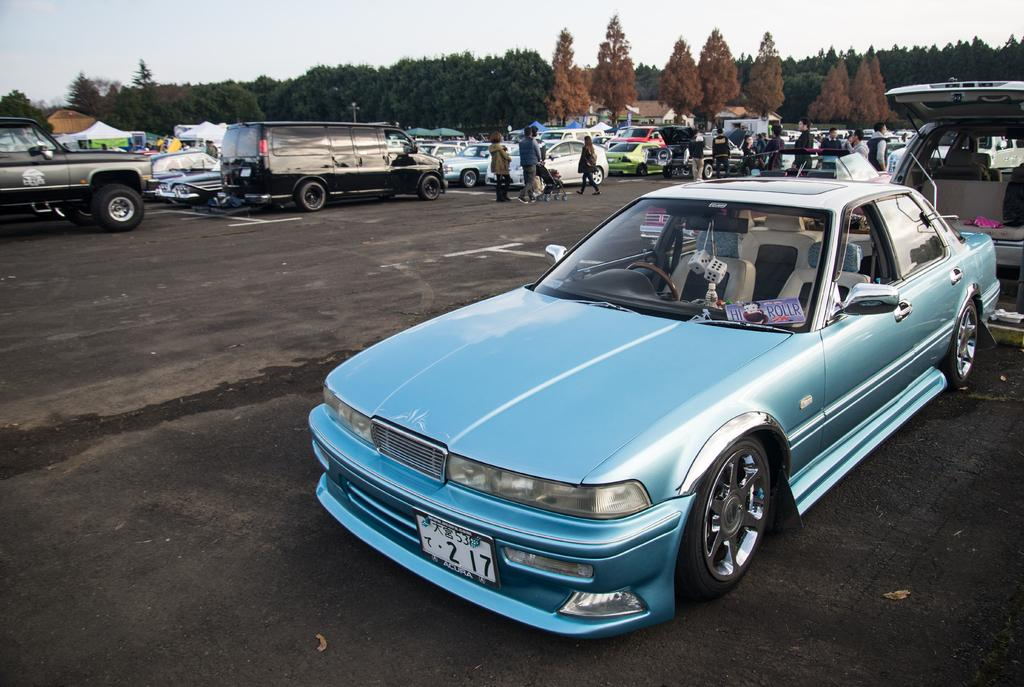What can be seen on the road in the image? There are vehicles parked on the road in the image. Who or what can be seen in the image besides the vehicles? There are people visible in the image. What type of structures are present in the image? There are stalls and houses in the image. What type of vegetation is present in the image? Trees are present in the image. What is visible at the top of the image? The sky is visible at the top of the image. How many chickens can be seen in the yard in the image? There is no yard or chickens present in the image. What is the chance of winning a prize at the stalls in the image? The image does not provide information about the stalls offering prizes or the chances of winning. 